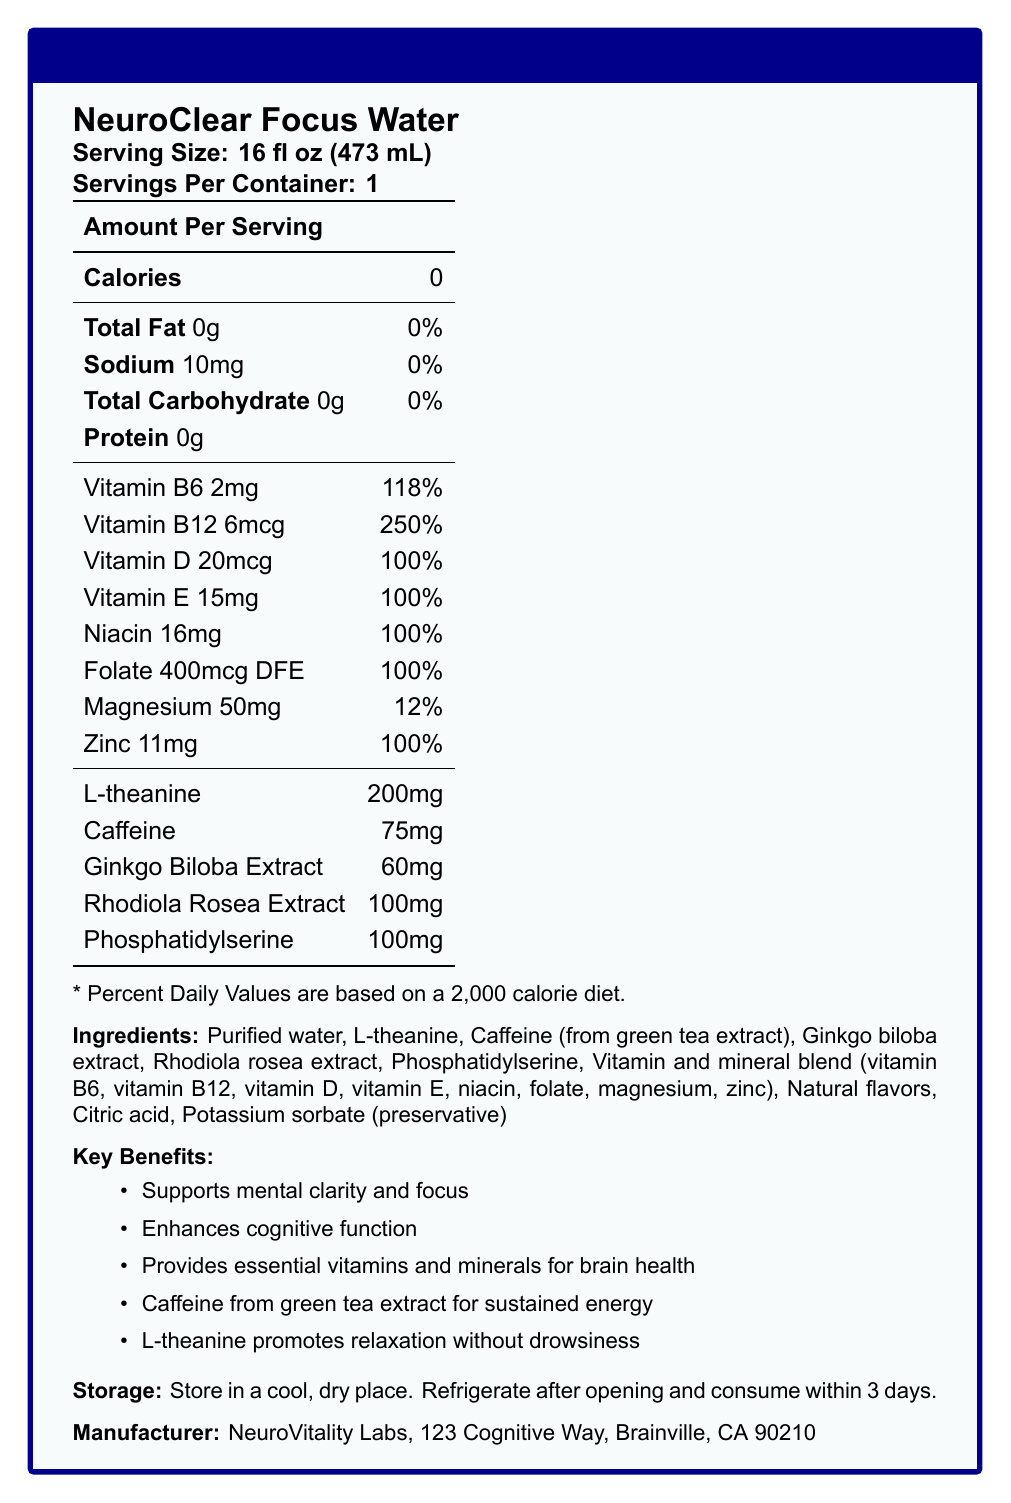what is the serving size of NeuroClear Focus Water? The serving size is explicitly mentioned in the document under the section labeled "Serving Size."
Answer: 16 fl oz (473 mL) how many servings are there per container? The document states "Servings Per Container: 1" directly beneath the serving size information.
Answer: 1 how many calories are in a serving of NeuroClear Focus Water? The number of calories is listed as "0" under the "Amount Per Serving" section.
Answer: 0 what is the amount of sodium in the product? The sodium content is listed as "10mg" in the nutritional breakdown.
Answer: 10mg what are the key benefits of NeuroClear Focus Water? These key benefits are listed in the document under "Key Benefits."
Answer: Supports mental clarity and focus, Enhances cognitive function, Provides essential vitamins and minerals for brain health, Caffeine from green tea extract for sustained energy, L-theanine promotes relaxation without drowsiness which vitamin has the highest percentage daily value in NeuroClear Focus Water? A. Vitamin B6 B. Vitamin B12 C. Vitamin D D. Vitamin E Vitamin B12 has a daily value of 250%, which is the highest among the vitamins listed.
Answer: B. Vitamin B12 how much folate is in a serving of NeuroClear Focus Water? A. 200mcg DFE B. 300mcg DFE C. 400mcg DFE D. 500mcg DFE The document indicates that the folate content is 400mcg DFE per serving.
Answer: C. 400mcg DFE does the product contain any carbohydrates? The total carbohydrate content is 0g per serving, as specified in the nutritional information.
Answer: No summarize the main idea of the document. The document outlines the product's nutritional content, key benefits, ingredients, and its target audience, emphasizing its cognitive support features.
Answer: NeuroClear Focus Water is a vitamin-fortified bottled water formulated to enhance mental clarity and focus. It contains essential vitamins, minerals, and nootropic compounds such as L-theanine, caffeine, and various herbal extracts. The product aims to support brain health and cognitive performance, particularly for students and professionals. who is the target audience for this product? The target audience is specified near the end of the document.
Answer: Students, professionals, and academics seeking to enhance their cognitive performance and maintain mental clarity throughout demanding tasks. can the storage instructions be found in the document? The document specifies "Store in a cool, dry place. Refrigerate after opening and consume within 3 days."
Answer: Yes is the amount of caffeine in the product greater than 100mg? The product contains 75mg of caffeine per serving, which is less than 100mg.
Answer: No where is the product manufactured? The manufacturer information is provided at the end of the document.
Answer: Produced by NeuroVitality Labs, 123 Cognitive Way, Brainville, CA 90210 what is the primary purpose of Phosphatidylserine in the product? The scientific basis section explains that Phosphatidylserine plays a crucial role in maintaining cellular function in the brain.
Answer: Maintaining cellular function in the brain what is the total amount of Rhodiola Rosea Extract included in the product? The amount of Rhodiola Rosea Extract is listed as 100mg in the nutritional information.
Answer: 100mg which ingredient is not a preservative in the product? A. Citric acid B. Potassium sorbate C. Purified water D. Natural flavors Citric acid and potassium sorbate are typically used as preservatives, and natural flavors are for taste, making purified water the correct answer.
Answer: C. Purified water 